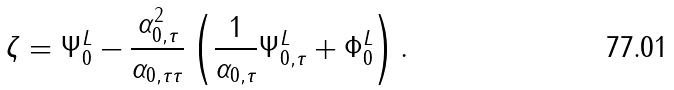Convert formula to latex. <formula><loc_0><loc_0><loc_500><loc_500>\zeta = \Psi _ { 0 } ^ { L } - \frac { \alpha _ { 0 , \tau } ^ { 2 } } { \alpha _ { 0 , \tau \tau } } \left ( \frac { 1 } { \alpha _ { 0 , \tau } } \Psi _ { 0 , \tau } ^ { L } + \Phi _ { 0 } ^ { L } \right ) .</formula> 